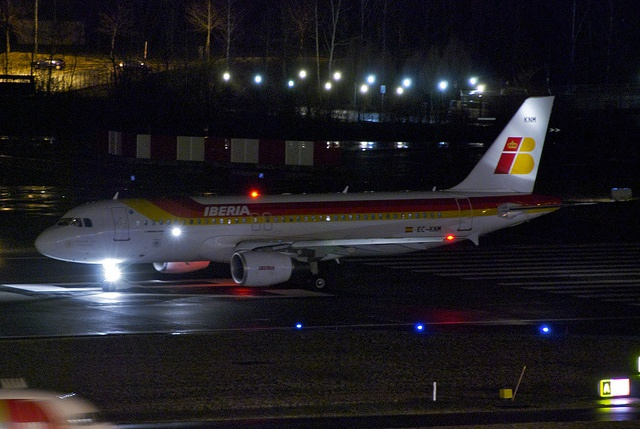Describe the objects in this image and their specific colors. I can see airplane in black, gray, and maroon tones and car in black and olive tones in this image. 